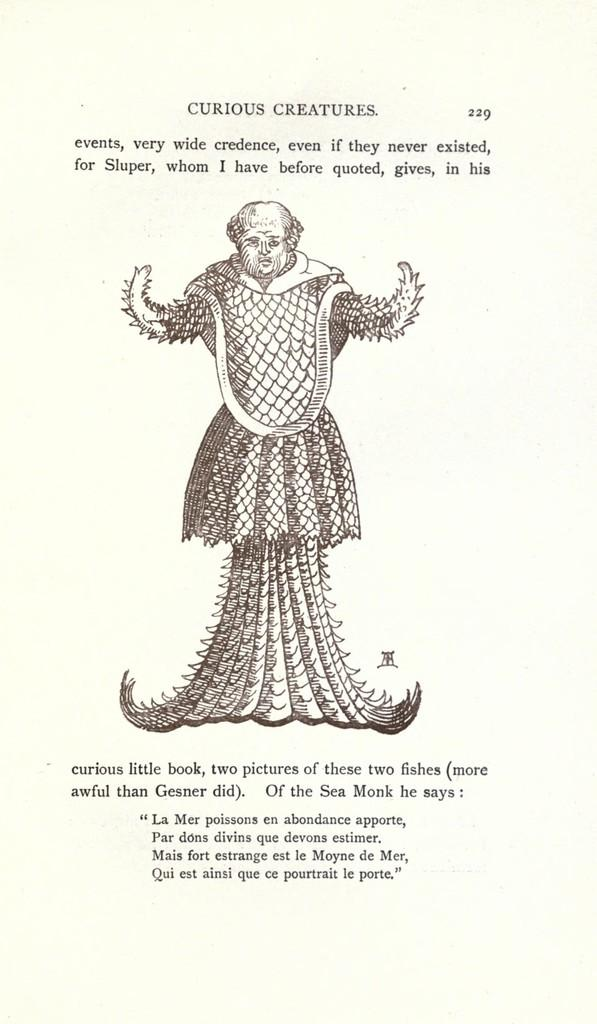What type of object is featured in the image? The image contains a page from a book. Can you describe the color of the page? The page is cream in color. What is depicted on the page? There is a sketch of a person on the page. How are the words on the page presented? The words on the page are written in black color. What type of jewel is being held by the person in the sketch? There is no jewel present in the sketch; it only depicts a person. What is the person in the sketch using to carry water? There is no pail or any indication of carrying water in the sketch; it only depicts a person. 